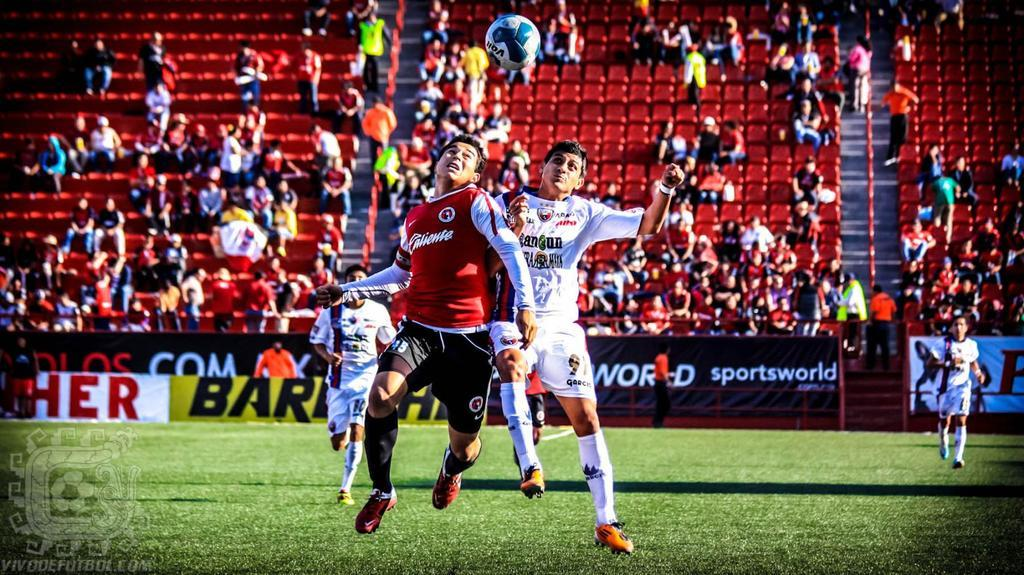Provide a one-sentence caption for the provided image. A group of players playing a soccer game sponsored by Sportsworld. 